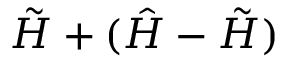<formula> <loc_0><loc_0><loc_500><loc_500>\tilde { H } + ( \hat { H } - \tilde { H } )</formula> 